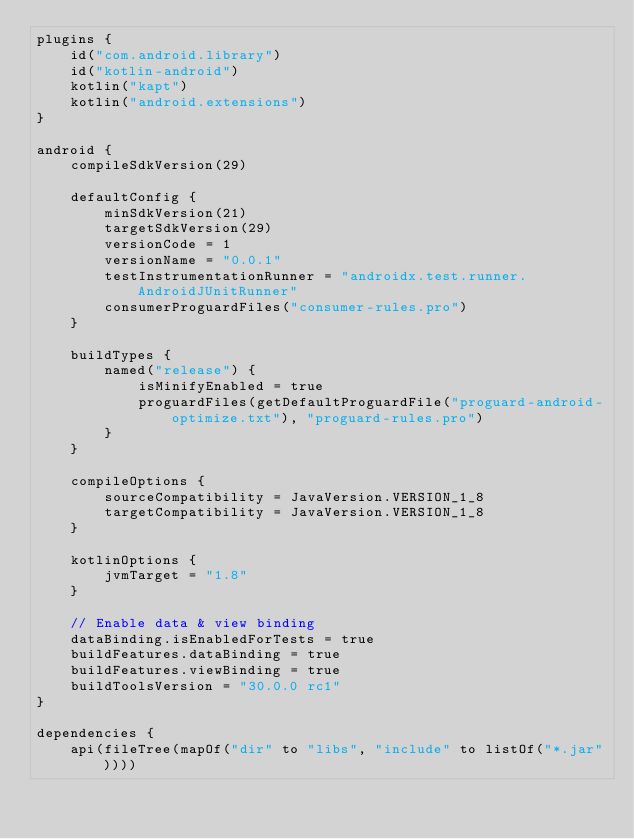<code> <loc_0><loc_0><loc_500><loc_500><_Kotlin_>plugins {
    id("com.android.library")
    id("kotlin-android")
    kotlin("kapt")
    kotlin("android.extensions")
}

android {
    compileSdkVersion(29)

    defaultConfig {
        minSdkVersion(21)
        targetSdkVersion(29)
        versionCode = 1
        versionName = "0.0.1"
        testInstrumentationRunner = "androidx.test.runner.AndroidJUnitRunner"
        consumerProguardFiles("consumer-rules.pro")
    }

    buildTypes {
        named("release") {
            isMinifyEnabled = true
            proguardFiles(getDefaultProguardFile("proguard-android-optimize.txt"), "proguard-rules.pro")
        }
    }

    compileOptions {
        sourceCompatibility = JavaVersion.VERSION_1_8
        targetCompatibility = JavaVersion.VERSION_1_8
    }

    kotlinOptions {
        jvmTarget = "1.8"
    }

    // Enable data & view binding
    dataBinding.isEnabledForTests = true
    buildFeatures.dataBinding = true
    buildFeatures.viewBinding = true
    buildToolsVersion = "30.0.0 rc1"
}

dependencies {
    api(fileTree(mapOf("dir" to "libs", "include" to listOf("*.jar"))))</code> 